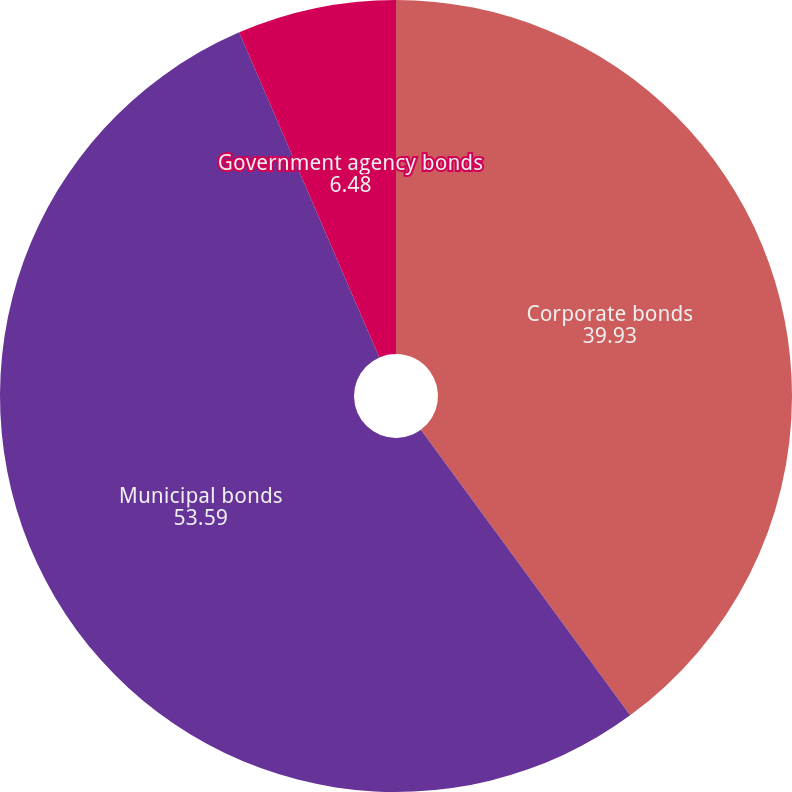<chart> <loc_0><loc_0><loc_500><loc_500><pie_chart><fcel>Corporate bonds<fcel>Municipal bonds<fcel>Government agency bonds<nl><fcel>39.93%<fcel>53.59%<fcel>6.48%<nl></chart> 